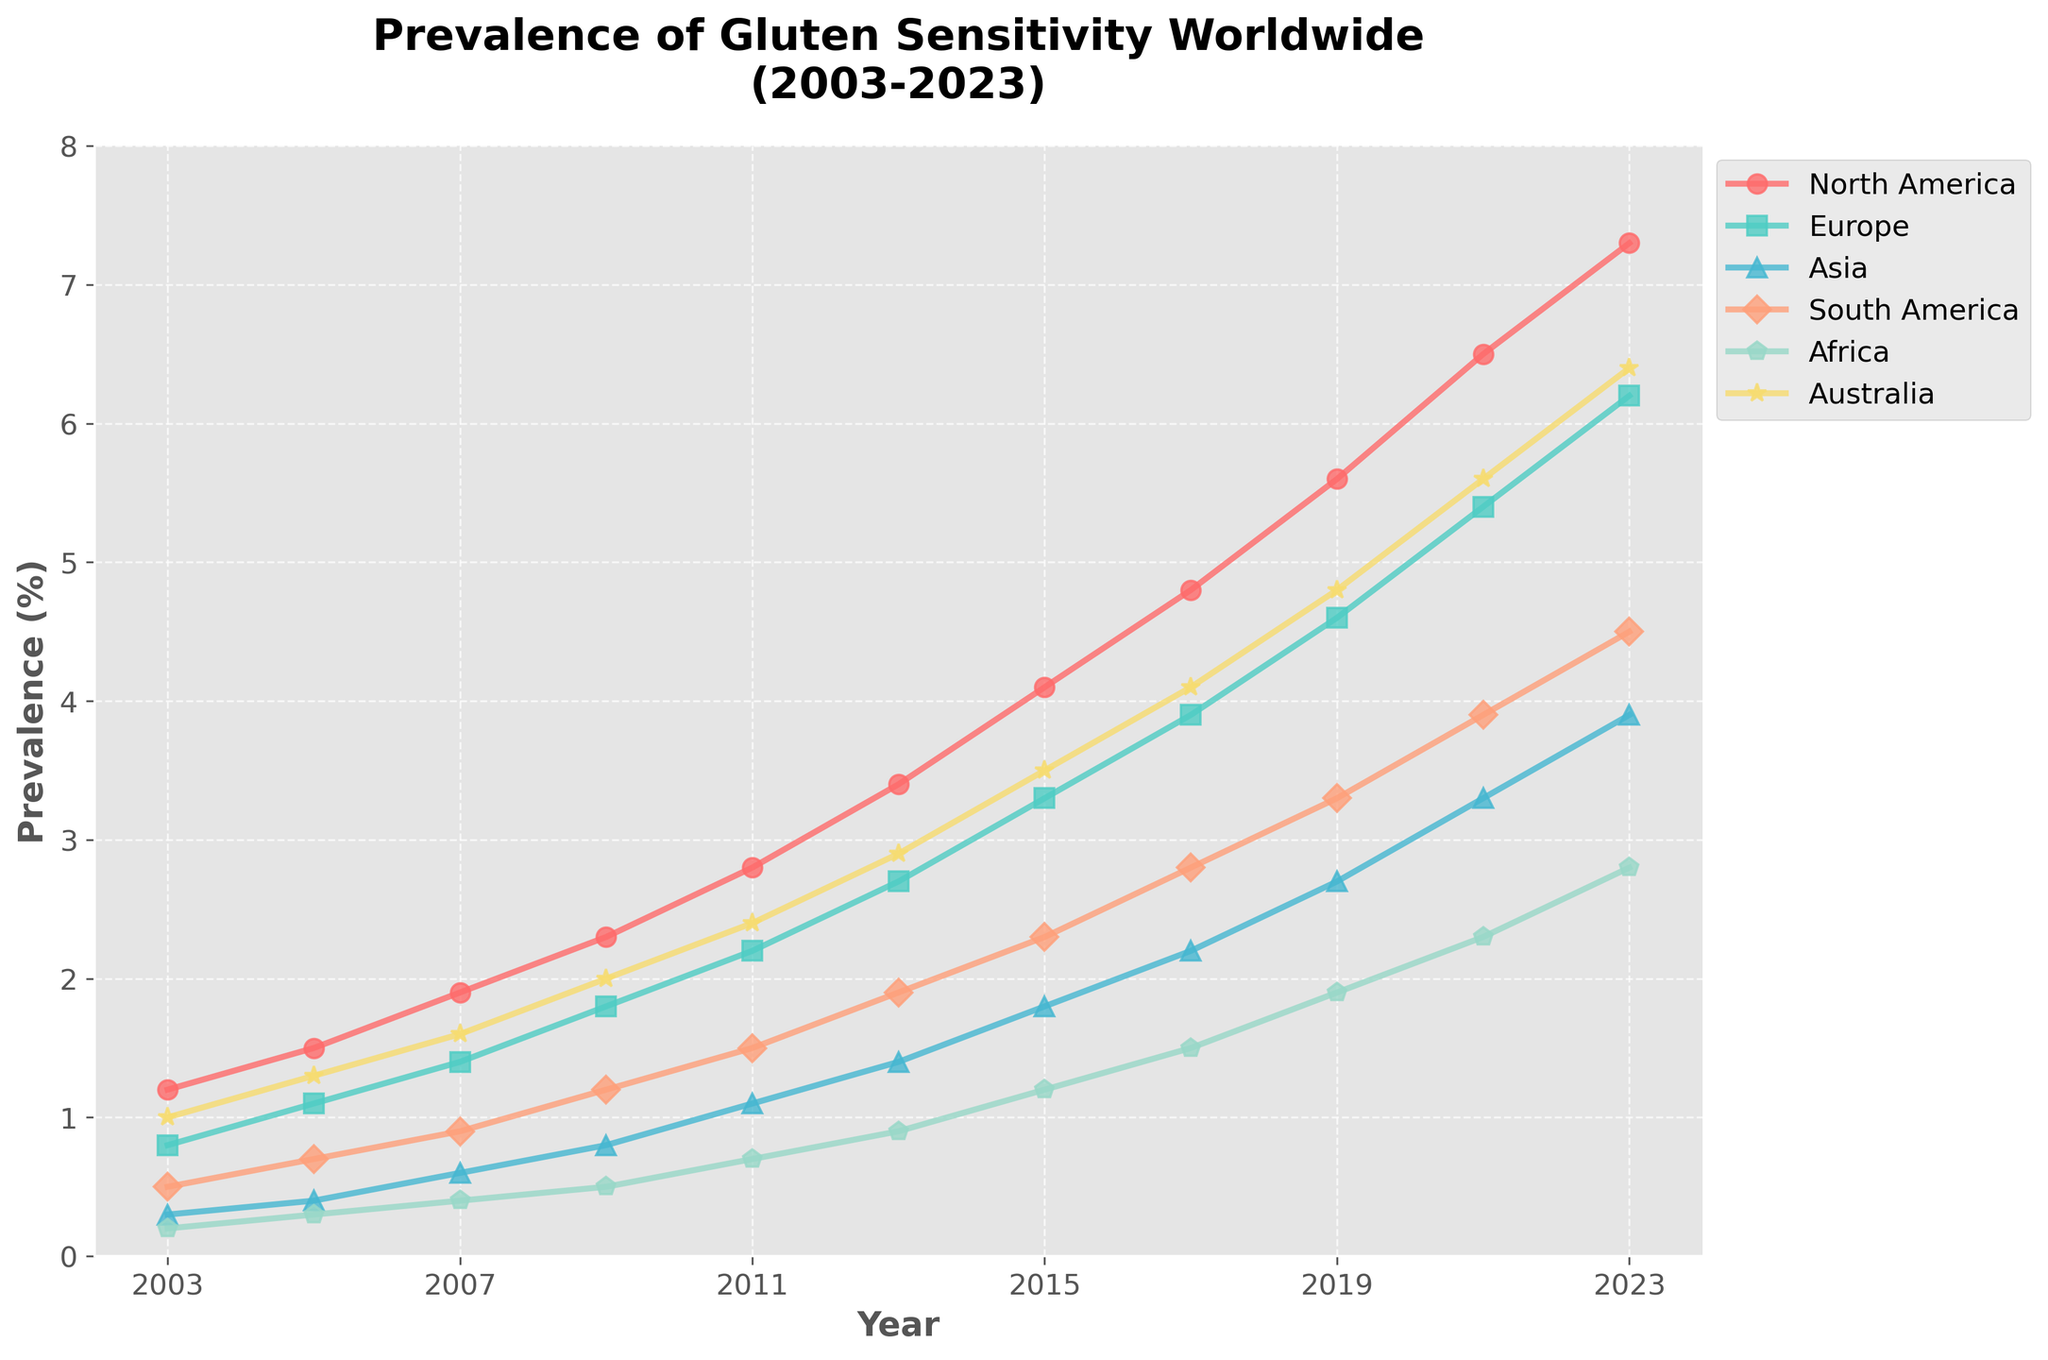What is the prevalence of gluten sensitivity in North America in 2003? Look at the line representing North America and identify the data point for the year 2003.
Answer: 1.2% Which continent had the highest prevalence of gluten sensitivity in 2023? Compare the data points for each continent in the year 2023.
Answer: North America How much did the prevalence in Asia increase from 2003 to 2023? Find the prevalence values for Asia in 2003 and 2023, then subtract the 2003 value from the 2023 value.
Answer: 3.6% By how much did the prevalence difference between Europe and Africa change from 2005 to 2015? Calculate the prevalence difference (Europe - Africa) for both years and then find the change by subtracting the 2005 difference from the 2015 difference.
Answer: 2.3% Which continent showed the highest rate of increase in gluten sensitivity between 2003 and 2023? Calculate the rate of increase for each continent by subtracting the 2003 value from the 2023 value and compare the results.
Answer: North America By how much did the prevalence of gluten sensitivity change in Australia from 2013 to 2023? Subtract the prevalence value in 2013 from the prevalence value in 2023 for Australia.
Answer: 3.5% Which two continents showed the least difference in prevalence in 2021? Compare the prevalence values for all continents in 2021 and find the two with the smallest difference.
Answer: South America and Africa In which year did Europe surpass a prevalence of 5%? Identify the year in the line for Europe where the prevalence first exceeds 5%.
Answer: 2021 What is the average prevalence of gluten sensitivity in Africa from 2003 to 2023? Sum the prevalence values for Africa from 2003 to 2023 and divide by the number of years (11).
Answer: 1.127% Compare the prevalence of gluten sensitivity in South America in 2003 and 2023. Was the increase greater than 4%? Calculate the increase by subtracting the 2003 value from the 2023 value for South America and check if it's greater than 4%.
Answer: No, it's not greater 